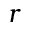<formula> <loc_0><loc_0><loc_500><loc_500>r</formula> 